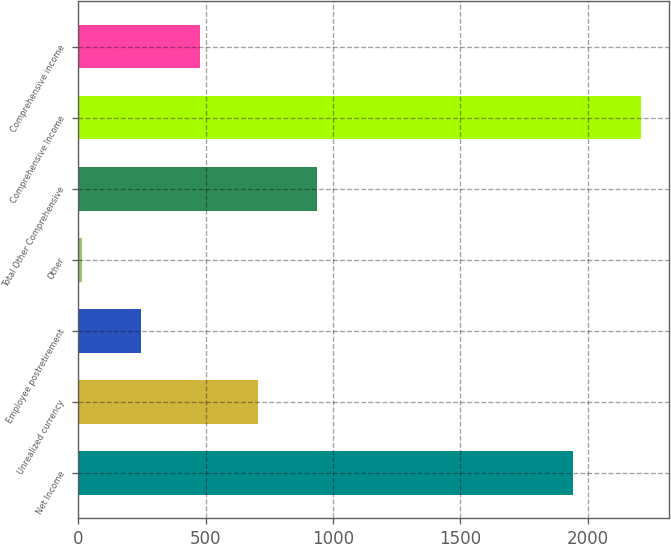Convert chart to OTSL. <chart><loc_0><loc_0><loc_500><loc_500><bar_chart><fcel>Net Income<fcel>Unrealized currency<fcel>Employee postretirement<fcel>Other<fcel>Total Other Comprehensive<fcel>Comprehensive Income<fcel>Comprehensive income<nl><fcel>1943<fcel>706<fcel>246<fcel>16<fcel>936<fcel>2210<fcel>476<nl></chart> 